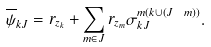Convert formula to latex. <formula><loc_0><loc_0><loc_500><loc_500>\overline { \psi } _ { k J } = r _ { z _ { k } } + \sum _ { m \in J } r _ { z _ { m } } \sigma ^ { m ( k \cup ( J \ m ) ) } _ { k J } .</formula> 